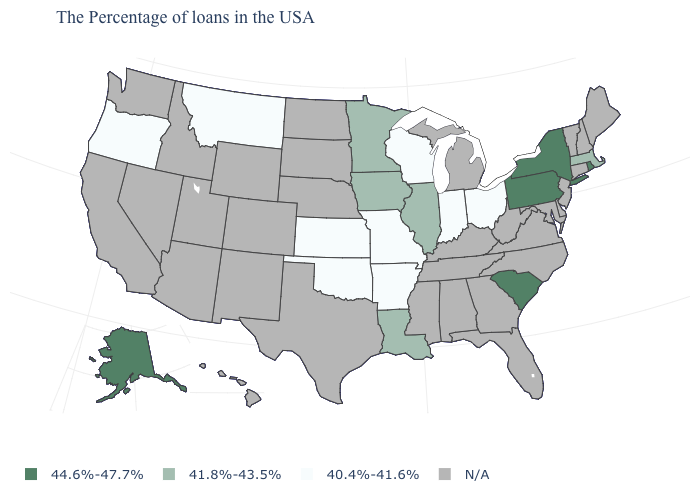Which states have the lowest value in the USA?
Short answer required. Ohio, Indiana, Wisconsin, Missouri, Arkansas, Kansas, Oklahoma, Montana, Oregon. Which states have the highest value in the USA?
Concise answer only. Rhode Island, New York, Pennsylvania, South Carolina, Alaska. Is the legend a continuous bar?
Write a very short answer. No. What is the value of Kansas?
Concise answer only. 40.4%-41.6%. Does Massachusetts have the lowest value in the USA?
Answer briefly. No. Among the states that border South Dakota , which have the lowest value?
Give a very brief answer. Montana. What is the value of South Carolina?
Concise answer only. 44.6%-47.7%. Among the states that border California , which have the highest value?
Answer briefly. Oregon. What is the value of Louisiana?
Short answer required. 41.8%-43.5%. What is the highest value in states that border West Virginia?
Keep it brief. 44.6%-47.7%. Which states have the lowest value in the South?
Give a very brief answer. Arkansas, Oklahoma. Name the states that have a value in the range 40.4%-41.6%?
Keep it brief. Ohio, Indiana, Wisconsin, Missouri, Arkansas, Kansas, Oklahoma, Montana, Oregon. 